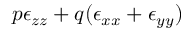<formula> <loc_0><loc_0><loc_500><loc_500>p \epsilon _ { z z } + q ( \epsilon _ { x x } + \epsilon _ { y y } )</formula> 